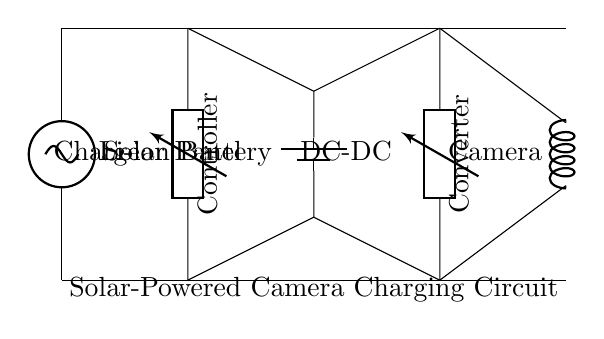What component collects solar energy? The component that collects solar energy is labeled as the solar panel at the top of the circuit diagram. It converts sunlight into electrical energy.
Answer: Solar Panel What type of battery is used in this circuit? The circuit diagram shows a lithium-ion battery, indicated by the label next to the component that stores electrical energy for later use.
Answer: Li-ion Battery What is the purpose of the charge controller? The charge controller regulates the voltage and current coming from the solar panel to ensure that the battery is charged safely and efficiently. This prevents overcharging and enhances battery life.
Answer: Charge Controller How many main components are visible in the circuit? There are five main components in the circuit: the solar panel, charge controller, lithium-ion battery, DC-DC converter, and camera load. This can be counted directly from the diagram.
Answer: Five What does the DC-DC converter do in this circuit? The DC-DC converter's role is to adjust the voltage levels from the battery to match the requirements of the camera load, ensuring compatibility and efficient operation when charging.
Answer: Adjust voltage levels What is the load in this circuit? The load in the circuit is the device that uses power, which is indicated as the camera, labeled at the bottom of the diagram. This component draws power from the battery for operation.
Answer: Camera What is the direction of current flow from the solar panel to the camera? The current flows from the top (solar panel) through the charge controller, into the battery, then through the DC-DC converter to the camera. This sequence can be inferred by following the connections in the diagram.
Answer: From solar panel to camera 